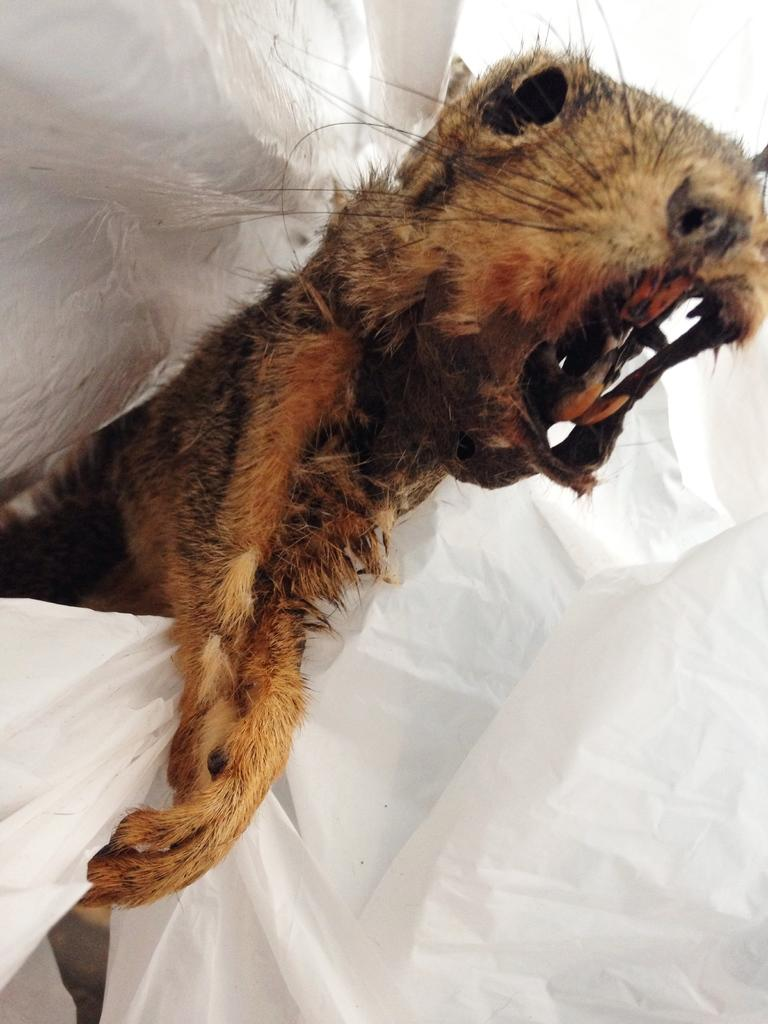What type of animal is present in the image? There is an animal in the image, but the specific type cannot be determined from the provided facts. What is the color of the blanket in the image? The blanket in the image is white. Is the animal stuck in quicksand in the image? There is no mention of quicksand in the image, so it cannot be determined if the animal is stuck in it. How many stars can be seen in the image? There is no mention of stars in the image, so it cannot be determined how many are present. 